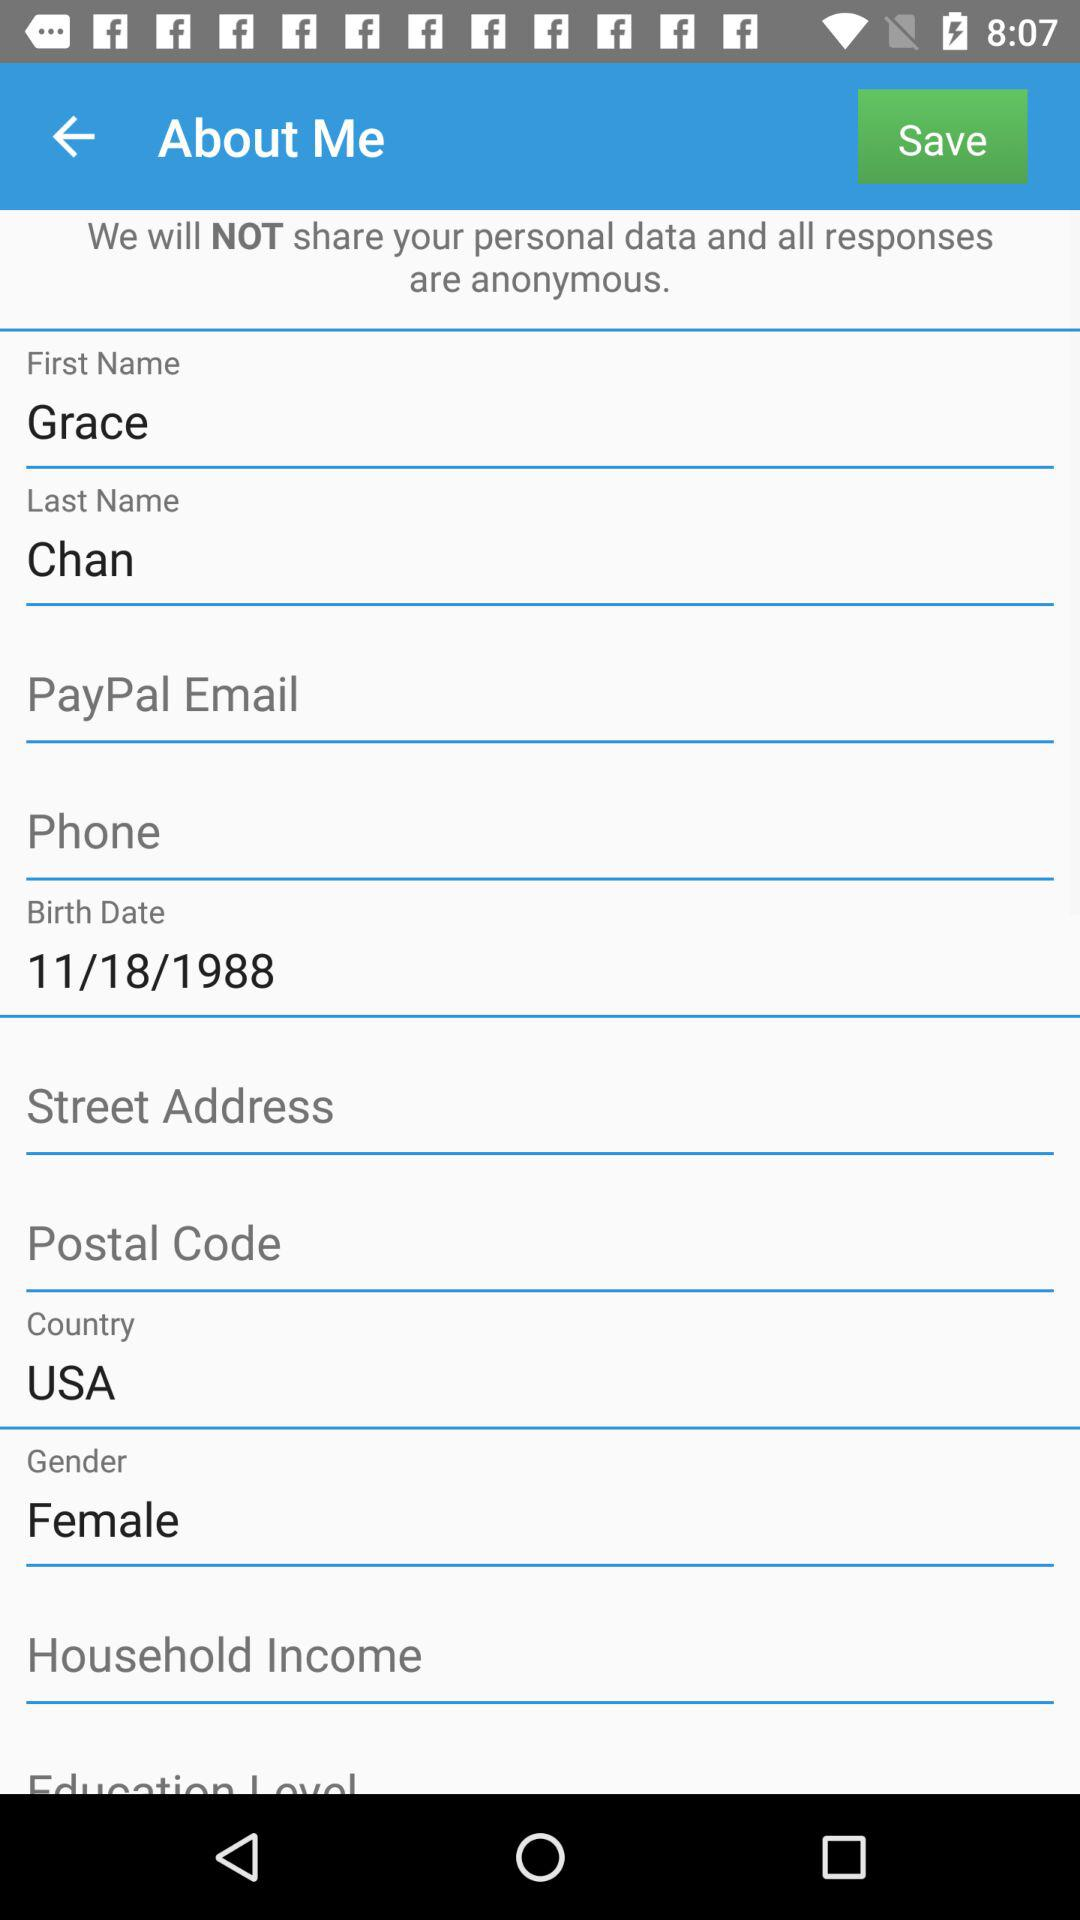What is the gender of the person? The gender is female. 